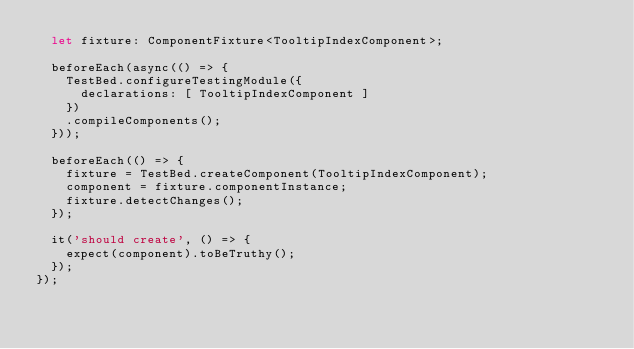<code> <loc_0><loc_0><loc_500><loc_500><_TypeScript_>  let fixture: ComponentFixture<TooltipIndexComponent>;

  beforeEach(async(() => {
    TestBed.configureTestingModule({
      declarations: [ TooltipIndexComponent ]
    })
    .compileComponents();
  }));

  beforeEach(() => {
    fixture = TestBed.createComponent(TooltipIndexComponent);
    component = fixture.componentInstance;
    fixture.detectChanges();
  });

  it('should create', () => {
    expect(component).toBeTruthy();
  });
});
</code> 